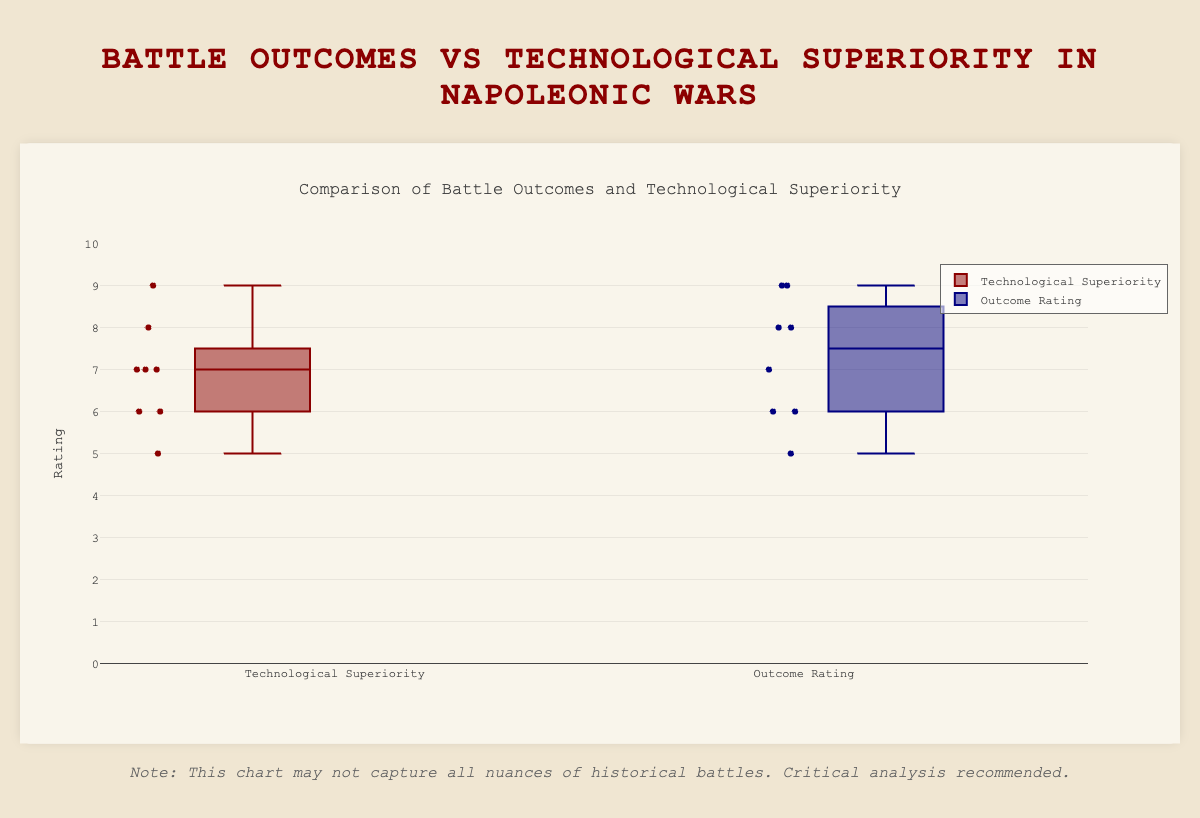What is the title of the figure? The title is usually displayed at the top of the figure and summarizes the main focus of the visualization. In this case, it should be easy to read from the top of the figure.
Answer: Comparison of Battle Outcomes and Technological Superiority What color represents Technological Superiority? Colors help distinguish different groups in a box plot. The color used for Technological Superiority can be observed by looking at the legend or the box color.
Answer: Red Which battle has the highest technological superiority? Each data point within the box plot is labeled by battle names. The highest value of Technological Superiority is the one that reaches the highest on the y-axis for the Technological Superiority box.
Answer: Jena–Auerstedt What is the median value of Outcome Rating? The median is generally represented by a line inside the box. By observing the Outcome Rating box, we can identify the median value.
Answer: 7 How many battles have an Outcome Rating higher than their Technological Superiority? By comparing each battle's Outcome Rating and Technological Superiority, identify the battles where the Outcome Rating exceeds Technological Superiority.
Answer: 3 battles Which group has a higher median rating: Technological Superiority or Outcome Rating? Identify the median lines in both box plots. Compare the two values to determine which is higher.
Answer: Technological Superiority What is the range (difference between maximum and minimum values) for Technological Superiority? Range can be calculated by identifying the maximum and minimum values from the top and bottom of the Technological Superiority box plot. The difference between these values gives the range.
Answer: 4 Which battle is represented by the lowest Outcome Rating? Identify the data point that is lowest on the y-axis within the Outcome Rating box plot and note the associated battle name.
Answer: Leipzig What is the average Outcome Rating across all battles? Sum all individual Outcome Ratings and divide by the total number of battles to get the average. The individual ratings are: 9, 7, 8, 6, 5, 8, 9, 6.
Answer: 7.25 Do battles with high Technological Superiority tend to have high Outcome Ratings? Observe if battles with higher values in the Technological Superiority plot generally have corresponding high values in the Outcome Rating plot.
Answer: Yes 